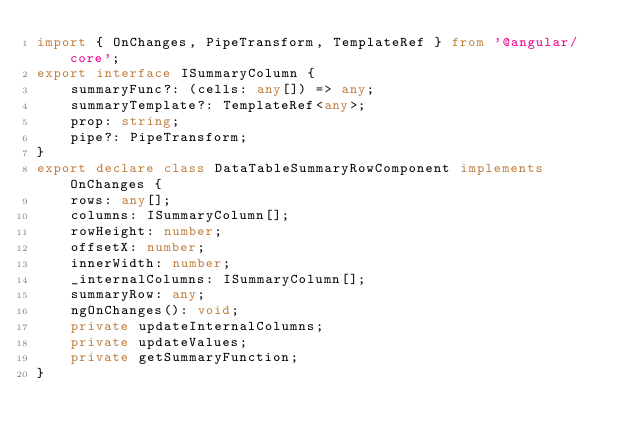<code> <loc_0><loc_0><loc_500><loc_500><_TypeScript_>import { OnChanges, PipeTransform, TemplateRef } from '@angular/core';
export interface ISummaryColumn {
    summaryFunc?: (cells: any[]) => any;
    summaryTemplate?: TemplateRef<any>;
    prop: string;
    pipe?: PipeTransform;
}
export declare class DataTableSummaryRowComponent implements OnChanges {
    rows: any[];
    columns: ISummaryColumn[];
    rowHeight: number;
    offsetX: number;
    innerWidth: number;
    _internalColumns: ISummaryColumn[];
    summaryRow: any;
    ngOnChanges(): void;
    private updateInternalColumns;
    private updateValues;
    private getSummaryFunction;
}
</code> 